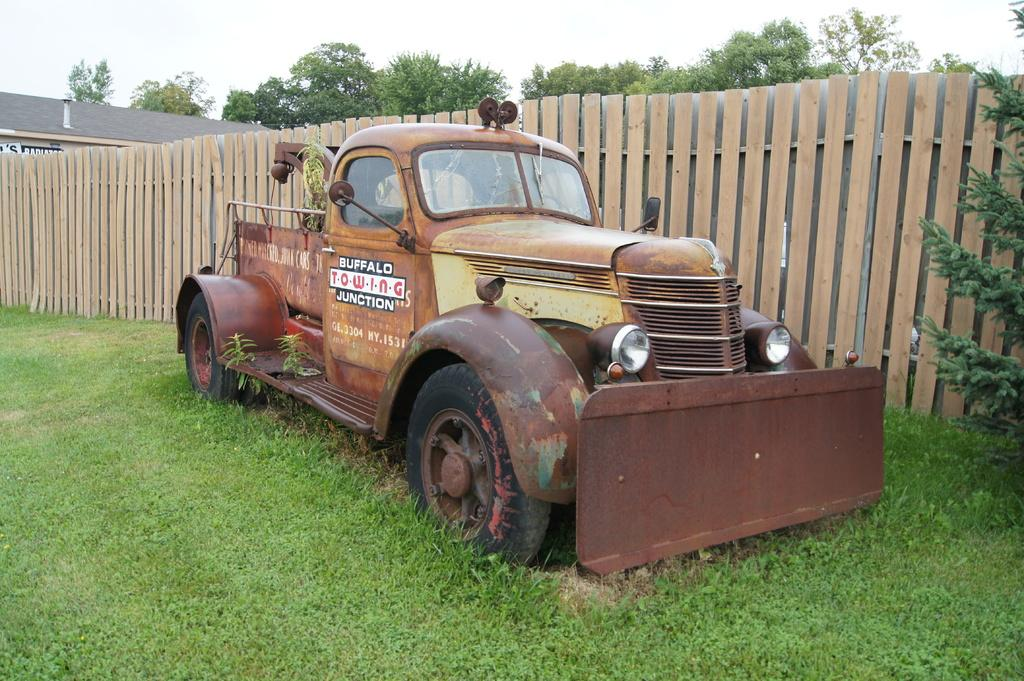What is located on the grass in the foreground of the image? There is a vehicle on the grass in the foreground of the image. What can be seen in the background of the image? There is a wooden railing, trees, a building, and the sky visible in the background of the image. What type of juice is being sold from the cart in the image? There is no cart present in the image, so it is not possible to determine what type of juice might be sold. 